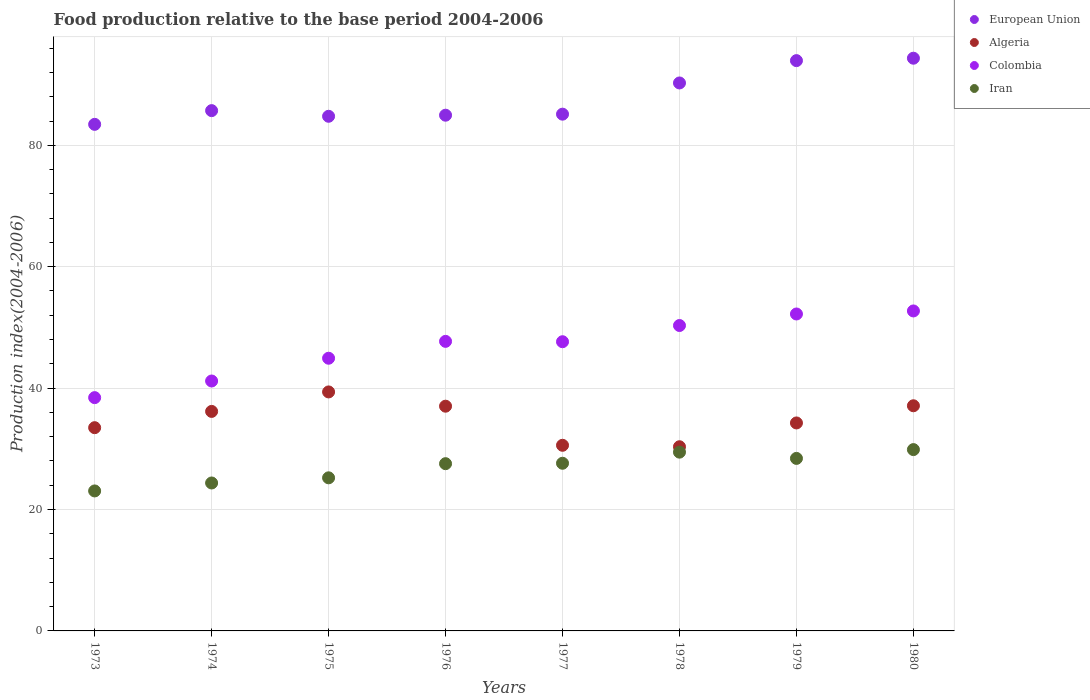Is the number of dotlines equal to the number of legend labels?
Ensure brevity in your answer.  Yes. What is the food production index in European Union in 1979?
Your answer should be compact. 93.95. Across all years, what is the maximum food production index in Colombia?
Provide a short and direct response. 52.71. Across all years, what is the minimum food production index in Iran?
Offer a terse response. 23.06. In which year was the food production index in Iran minimum?
Your answer should be compact. 1973. What is the total food production index in European Union in the graph?
Your response must be concise. 702.58. What is the difference between the food production index in Colombia in 1976 and that in 1979?
Keep it short and to the point. -4.51. What is the difference between the food production index in Colombia in 1979 and the food production index in Algeria in 1978?
Offer a very short reply. 21.87. What is the average food production index in Iran per year?
Offer a terse response. 26.95. In the year 1979, what is the difference between the food production index in Iran and food production index in Colombia?
Provide a short and direct response. -23.79. In how many years, is the food production index in Colombia greater than 60?
Your response must be concise. 0. What is the ratio of the food production index in European Union in 1978 to that in 1980?
Your response must be concise. 0.96. Is the food production index in European Union in 1974 less than that in 1980?
Ensure brevity in your answer.  Yes. Is the difference between the food production index in Iran in 1973 and 1975 greater than the difference between the food production index in Colombia in 1973 and 1975?
Your answer should be very brief. Yes. What is the difference between the highest and the lowest food production index in European Union?
Ensure brevity in your answer.  10.89. Is the sum of the food production index in European Union in 1974 and 1980 greater than the maximum food production index in Iran across all years?
Ensure brevity in your answer.  Yes. Does the food production index in Algeria monotonically increase over the years?
Keep it short and to the point. No. Is the food production index in Algeria strictly greater than the food production index in European Union over the years?
Your answer should be very brief. No. Is the food production index in European Union strictly less than the food production index in Iran over the years?
Make the answer very short. No. How many dotlines are there?
Keep it short and to the point. 4. How many years are there in the graph?
Provide a short and direct response. 8. Where does the legend appear in the graph?
Your answer should be very brief. Top right. How many legend labels are there?
Offer a very short reply. 4. What is the title of the graph?
Make the answer very short. Food production relative to the base period 2004-2006. Does "Turkmenistan" appear as one of the legend labels in the graph?
Provide a short and direct response. No. What is the label or title of the Y-axis?
Your response must be concise. Production index(2004-2006). What is the Production index(2004-2006) in European Union in 1973?
Give a very brief answer. 83.45. What is the Production index(2004-2006) in Algeria in 1973?
Ensure brevity in your answer.  33.48. What is the Production index(2004-2006) in Colombia in 1973?
Your answer should be compact. 38.43. What is the Production index(2004-2006) in Iran in 1973?
Give a very brief answer. 23.06. What is the Production index(2004-2006) of European Union in 1974?
Make the answer very short. 85.71. What is the Production index(2004-2006) in Algeria in 1974?
Provide a short and direct response. 36.16. What is the Production index(2004-2006) in Colombia in 1974?
Offer a very short reply. 41.17. What is the Production index(2004-2006) of Iran in 1974?
Provide a short and direct response. 24.37. What is the Production index(2004-2006) in European Union in 1975?
Your answer should be compact. 84.78. What is the Production index(2004-2006) in Algeria in 1975?
Ensure brevity in your answer.  39.37. What is the Production index(2004-2006) of Colombia in 1975?
Offer a terse response. 44.92. What is the Production index(2004-2006) in Iran in 1975?
Your answer should be compact. 25.22. What is the Production index(2004-2006) of European Union in 1976?
Provide a succinct answer. 84.96. What is the Production index(2004-2006) of Algeria in 1976?
Your response must be concise. 37.02. What is the Production index(2004-2006) of Colombia in 1976?
Make the answer very short. 47.7. What is the Production index(2004-2006) of Iran in 1976?
Make the answer very short. 27.55. What is the Production index(2004-2006) in European Union in 1977?
Give a very brief answer. 85.13. What is the Production index(2004-2006) in Algeria in 1977?
Your answer should be compact. 30.58. What is the Production index(2004-2006) in Colombia in 1977?
Give a very brief answer. 47.64. What is the Production index(2004-2006) in Iran in 1977?
Provide a succinct answer. 27.62. What is the Production index(2004-2006) in European Union in 1978?
Offer a terse response. 90.27. What is the Production index(2004-2006) of Algeria in 1978?
Give a very brief answer. 30.34. What is the Production index(2004-2006) in Colombia in 1978?
Keep it short and to the point. 50.31. What is the Production index(2004-2006) of Iran in 1978?
Your answer should be very brief. 29.45. What is the Production index(2004-2006) in European Union in 1979?
Make the answer very short. 93.95. What is the Production index(2004-2006) of Algeria in 1979?
Your response must be concise. 34.26. What is the Production index(2004-2006) of Colombia in 1979?
Your answer should be very brief. 52.21. What is the Production index(2004-2006) of Iran in 1979?
Offer a very short reply. 28.42. What is the Production index(2004-2006) of European Union in 1980?
Your answer should be very brief. 94.34. What is the Production index(2004-2006) of Algeria in 1980?
Your answer should be very brief. 37.09. What is the Production index(2004-2006) of Colombia in 1980?
Provide a succinct answer. 52.71. What is the Production index(2004-2006) in Iran in 1980?
Your answer should be very brief. 29.87. Across all years, what is the maximum Production index(2004-2006) in European Union?
Your answer should be very brief. 94.34. Across all years, what is the maximum Production index(2004-2006) of Algeria?
Keep it short and to the point. 39.37. Across all years, what is the maximum Production index(2004-2006) in Colombia?
Provide a succinct answer. 52.71. Across all years, what is the maximum Production index(2004-2006) of Iran?
Offer a terse response. 29.87. Across all years, what is the minimum Production index(2004-2006) of European Union?
Provide a succinct answer. 83.45. Across all years, what is the minimum Production index(2004-2006) of Algeria?
Your answer should be very brief. 30.34. Across all years, what is the minimum Production index(2004-2006) in Colombia?
Give a very brief answer. 38.43. Across all years, what is the minimum Production index(2004-2006) of Iran?
Your answer should be very brief. 23.06. What is the total Production index(2004-2006) in European Union in the graph?
Give a very brief answer. 702.58. What is the total Production index(2004-2006) of Algeria in the graph?
Provide a succinct answer. 278.3. What is the total Production index(2004-2006) of Colombia in the graph?
Offer a terse response. 375.09. What is the total Production index(2004-2006) of Iran in the graph?
Ensure brevity in your answer.  215.56. What is the difference between the Production index(2004-2006) in European Union in 1973 and that in 1974?
Give a very brief answer. -2.26. What is the difference between the Production index(2004-2006) in Algeria in 1973 and that in 1974?
Ensure brevity in your answer.  -2.68. What is the difference between the Production index(2004-2006) in Colombia in 1973 and that in 1974?
Ensure brevity in your answer.  -2.74. What is the difference between the Production index(2004-2006) in Iran in 1973 and that in 1974?
Your answer should be very brief. -1.31. What is the difference between the Production index(2004-2006) of European Union in 1973 and that in 1975?
Make the answer very short. -1.33. What is the difference between the Production index(2004-2006) in Algeria in 1973 and that in 1975?
Keep it short and to the point. -5.89. What is the difference between the Production index(2004-2006) in Colombia in 1973 and that in 1975?
Offer a terse response. -6.49. What is the difference between the Production index(2004-2006) in Iran in 1973 and that in 1975?
Make the answer very short. -2.16. What is the difference between the Production index(2004-2006) in European Union in 1973 and that in 1976?
Keep it short and to the point. -1.51. What is the difference between the Production index(2004-2006) of Algeria in 1973 and that in 1976?
Ensure brevity in your answer.  -3.54. What is the difference between the Production index(2004-2006) in Colombia in 1973 and that in 1976?
Your response must be concise. -9.27. What is the difference between the Production index(2004-2006) in Iran in 1973 and that in 1976?
Provide a short and direct response. -4.49. What is the difference between the Production index(2004-2006) in European Union in 1973 and that in 1977?
Provide a succinct answer. -1.68. What is the difference between the Production index(2004-2006) of Colombia in 1973 and that in 1977?
Offer a very short reply. -9.21. What is the difference between the Production index(2004-2006) in Iran in 1973 and that in 1977?
Your answer should be very brief. -4.56. What is the difference between the Production index(2004-2006) of European Union in 1973 and that in 1978?
Your response must be concise. -6.82. What is the difference between the Production index(2004-2006) of Algeria in 1973 and that in 1978?
Provide a short and direct response. 3.14. What is the difference between the Production index(2004-2006) of Colombia in 1973 and that in 1978?
Ensure brevity in your answer.  -11.88. What is the difference between the Production index(2004-2006) of Iran in 1973 and that in 1978?
Offer a very short reply. -6.39. What is the difference between the Production index(2004-2006) of European Union in 1973 and that in 1979?
Make the answer very short. -10.5. What is the difference between the Production index(2004-2006) in Algeria in 1973 and that in 1979?
Your answer should be compact. -0.78. What is the difference between the Production index(2004-2006) in Colombia in 1973 and that in 1979?
Give a very brief answer. -13.78. What is the difference between the Production index(2004-2006) of Iran in 1973 and that in 1979?
Give a very brief answer. -5.36. What is the difference between the Production index(2004-2006) in European Union in 1973 and that in 1980?
Offer a terse response. -10.89. What is the difference between the Production index(2004-2006) in Algeria in 1973 and that in 1980?
Offer a very short reply. -3.61. What is the difference between the Production index(2004-2006) in Colombia in 1973 and that in 1980?
Give a very brief answer. -14.28. What is the difference between the Production index(2004-2006) in Iran in 1973 and that in 1980?
Make the answer very short. -6.81. What is the difference between the Production index(2004-2006) of European Union in 1974 and that in 1975?
Your answer should be very brief. 0.93. What is the difference between the Production index(2004-2006) of Algeria in 1974 and that in 1975?
Your answer should be compact. -3.21. What is the difference between the Production index(2004-2006) in Colombia in 1974 and that in 1975?
Your answer should be compact. -3.75. What is the difference between the Production index(2004-2006) of Iran in 1974 and that in 1975?
Your response must be concise. -0.85. What is the difference between the Production index(2004-2006) of European Union in 1974 and that in 1976?
Your answer should be very brief. 0.75. What is the difference between the Production index(2004-2006) of Algeria in 1974 and that in 1976?
Your response must be concise. -0.86. What is the difference between the Production index(2004-2006) of Colombia in 1974 and that in 1976?
Your answer should be compact. -6.53. What is the difference between the Production index(2004-2006) of Iran in 1974 and that in 1976?
Keep it short and to the point. -3.18. What is the difference between the Production index(2004-2006) of European Union in 1974 and that in 1977?
Offer a terse response. 0.58. What is the difference between the Production index(2004-2006) in Algeria in 1974 and that in 1977?
Your response must be concise. 5.58. What is the difference between the Production index(2004-2006) in Colombia in 1974 and that in 1977?
Offer a very short reply. -6.47. What is the difference between the Production index(2004-2006) in Iran in 1974 and that in 1977?
Your answer should be very brief. -3.25. What is the difference between the Production index(2004-2006) of European Union in 1974 and that in 1978?
Offer a terse response. -4.56. What is the difference between the Production index(2004-2006) of Algeria in 1974 and that in 1978?
Give a very brief answer. 5.82. What is the difference between the Production index(2004-2006) in Colombia in 1974 and that in 1978?
Offer a very short reply. -9.14. What is the difference between the Production index(2004-2006) of Iran in 1974 and that in 1978?
Make the answer very short. -5.08. What is the difference between the Production index(2004-2006) of European Union in 1974 and that in 1979?
Make the answer very short. -8.24. What is the difference between the Production index(2004-2006) of Algeria in 1974 and that in 1979?
Make the answer very short. 1.9. What is the difference between the Production index(2004-2006) in Colombia in 1974 and that in 1979?
Ensure brevity in your answer.  -11.04. What is the difference between the Production index(2004-2006) of Iran in 1974 and that in 1979?
Your answer should be compact. -4.05. What is the difference between the Production index(2004-2006) of European Union in 1974 and that in 1980?
Your response must be concise. -8.64. What is the difference between the Production index(2004-2006) in Algeria in 1974 and that in 1980?
Give a very brief answer. -0.93. What is the difference between the Production index(2004-2006) in Colombia in 1974 and that in 1980?
Ensure brevity in your answer.  -11.54. What is the difference between the Production index(2004-2006) of European Union in 1975 and that in 1976?
Provide a succinct answer. -0.18. What is the difference between the Production index(2004-2006) in Algeria in 1975 and that in 1976?
Provide a succinct answer. 2.35. What is the difference between the Production index(2004-2006) of Colombia in 1975 and that in 1976?
Make the answer very short. -2.78. What is the difference between the Production index(2004-2006) in Iran in 1975 and that in 1976?
Make the answer very short. -2.33. What is the difference between the Production index(2004-2006) of European Union in 1975 and that in 1977?
Give a very brief answer. -0.35. What is the difference between the Production index(2004-2006) in Algeria in 1975 and that in 1977?
Ensure brevity in your answer.  8.79. What is the difference between the Production index(2004-2006) of Colombia in 1975 and that in 1977?
Give a very brief answer. -2.72. What is the difference between the Production index(2004-2006) in European Union in 1975 and that in 1978?
Keep it short and to the point. -5.49. What is the difference between the Production index(2004-2006) of Algeria in 1975 and that in 1978?
Offer a very short reply. 9.03. What is the difference between the Production index(2004-2006) in Colombia in 1975 and that in 1978?
Keep it short and to the point. -5.39. What is the difference between the Production index(2004-2006) of Iran in 1975 and that in 1978?
Provide a short and direct response. -4.23. What is the difference between the Production index(2004-2006) of European Union in 1975 and that in 1979?
Keep it short and to the point. -9.17. What is the difference between the Production index(2004-2006) in Algeria in 1975 and that in 1979?
Your answer should be very brief. 5.11. What is the difference between the Production index(2004-2006) of Colombia in 1975 and that in 1979?
Your answer should be very brief. -7.29. What is the difference between the Production index(2004-2006) in Iran in 1975 and that in 1979?
Offer a very short reply. -3.2. What is the difference between the Production index(2004-2006) in European Union in 1975 and that in 1980?
Offer a terse response. -9.57. What is the difference between the Production index(2004-2006) in Algeria in 1975 and that in 1980?
Your response must be concise. 2.28. What is the difference between the Production index(2004-2006) in Colombia in 1975 and that in 1980?
Offer a terse response. -7.79. What is the difference between the Production index(2004-2006) of Iran in 1975 and that in 1980?
Offer a terse response. -4.65. What is the difference between the Production index(2004-2006) in European Union in 1976 and that in 1977?
Provide a succinct answer. -0.17. What is the difference between the Production index(2004-2006) in Algeria in 1976 and that in 1977?
Your answer should be very brief. 6.44. What is the difference between the Production index(2004-2006) in Iran in 1976 and that in 1977?
Provide a succinct answer. -0.07. What is the difference between the Production index(2004-2006) in European Union in 1976 and that in 1978?
Make the answer very short. -5.31. What is the difference between the Production index(2004-2006) in Algeria in 1976 and that in 1978?
Offer a terse response. 6.68. What is the difference between the Production index(2004-2006) of Colombia in 1976 and that in 1978?
Keep it short and to the point. -2.61. What is the difference between the Production index(2004-2006) in European Union in 1976 and that in 1979?
Your answer should be compact. -8.99. What is the difference between the Production index(2004-2006) in Algeria in 1976 and that in 1979?
Your answer should be compact. 2.76. What is the difference between the Production index(2004-2006) of Colombia in 1976 and that in 1979?
Keep it short and to the point. -4.51. What is the difference between the Production index(2004-2006) of Iran in 1976 and that in 1979?
Provide a short and direct response. -0.87. What is the difference between the Production index(2004-2006) of European Union in 1976 and that in 1980?
Give a very brief answer. -9.39. What is the difference between the Production index(2004-2006) of Algeria in 1976 and that in 1980?
Your response must be concise. -0.07. What is the difference between the Production index(2004-2006) of Colombia in 1976 and that in 1980?
Your answer should be compact. -5.01. What is the difference between the Production index(2004-2006) of Iran in 1976 and that in 1980?
Your answer should be compact. -2.32. What is the difference between the Production index(2004-2006) in European Union in 1977 and that in 1978?
Provide a succinct answer. -5.14. What is the difference between the Production index(2004-2006) in Algeria in 1977 and that in 1978?
Your answer should be very brief. 0.24. What is the difference between the Production index(2004-2006) of Colombia in 1977 and that in 1978?
Your answer should be very brief. -2.67. What is the difference between the Production index(2004-2006) of Iran in 1977 and that in 1978?
Offer a very short reply. -1.83. What is the difference between the Production index(2004-2006) in European Union in 1977 and that in 1979?
Ensure brevity in your answer.  -8.82. What is the difference between the Production index(2004-2006) of Algeria in 1977 and that in 1979?
Keep it short and to the point. -3.68. What is the difference between the Production index(2004-2006) of Colombia in 1977 and that in 1979?
Keep it short and to the point. -4.57. What is the difference between the Production index(2004-2006) in Iran in 1977 and that in 1979?
Keep it short and to the point. -0.8. What is the difference between the Production index(2004-2006) of European Union in 1977 and that in 1980?
Give a very brief answer. -9.22. What is the difference between the Production index(2004-2006) of Algeria in 1977 and that in 1980?
Ensure brevity in your answer.  -6.51. What is the difference between the Production index(2004-2006) of Colombia in 1977 and that in 1980?
Give a very brief answer. -5.07. What is the difference between the Production index(2004-2006) of Iran in 1977 and that in 1980?
Provide a short and direct response. -2.25. What is the difference between the Production index(2004-2006) in European Union in 1978 and that in 1979?
Your answer should be very brief. -3.68. What is the difference between the Production index(2004-2006) of Algeria in 1978 and that in 1979?
Give a very brief answer. -3.92. What is the difference between the Production index(2004-2006) in Iran in 1978 and that in 1979?
Make the answer very short. 1.03. What is the difference between the Production index(2004-2006) of European Union in 1978 and that in 1980?
Make the answer very short. -4.08. What is the difference between the Production index(2004-2006) in Algeria in 1978 and that in 1980?
Offer a terse response. -6.75. What is the difference between the Production index(2004-2006) in Iran in 1978 and that in 1980?
Ensure brevity in your answer.  -0.42. What is the difference between the Production index(2004-2006) of European Union in 1979 and that in 1980?
Give a very brief answer. -0.4. What is the difference between the Production index(2004-2006) in Algeria in 1979 and that in 1980?
Give a very brief answer. -2.83. What is the difference between the Production index(2004-2006) in Iran in 1979 and that in 1980?
Keep it short and to the point. -1.45. What is the difference between the Production index(2004-2006) in European Union in 1973 and the Production index(2004-2006) in Algeria in 1974?
Provide a succinct answer. 47.29. What is the difference between the Production index(2004-2006) of European Union in 1973 and the Production index(2004-2006) of Colombia in 1974?
Your answer should be very brief. 42.28. What is the difference between the Production index(2004-2006) of European Union in 1973 and the Production index(2004-2006) of Iran in 1974?
Make the answer very short. 59.08. What is the difference between the Production index(2004-2006) of Algeria in 1973 and the Production index(2004-2006) of Colombia in 1974?
Offer a terse response. -7.69. What is the difference between the Production index(2004-2006) of Algeria in 1973 and the Production index(2004-2006) of Iran in 1974?
Your answer should be very brief. 9.11. What is the difference between the Production index(2004-2006) of Colombia in 1973 and the Production index(2004-2006) of Iran in 1974?
Offer a terse response. 14.06. What is the difference between the Production index(2004-2006) in European Union in 1973 and the Production index(2004-2006) in Algeria in 1975?
Make the answer very short. 44.08. What is the difference between the Production index(2004-2006) of European Union in 1973 and the Production index(2004-2006) of Colombia in 1975?
Provide a short and direct response. 38.53. What is the difference between the Production index(2004-2006) in European Union in 1973 and the Production index(2004-2006) in Iran in 1975?
Ensure brevity in your answer.  58.23. What is the difference between the Production index(2004-2006) of Algeria in 1973 and the Production index(2004-2006) of Colombia in 1975?
Offer a terse response. -11.44. What is the difference between the Production index(2004-2006) of Algeria in 1973 and the Production index(2004-2006) of Iran in 1975?
Ensure brevity in your answer.  8.26. What is the difference between the Production index(2004-2006) in Colombia in 1973 and the Production index(2004-2006) in Iran in 1975?
Keep it short and to the point. 13.21. What is the difference between the Production index(2004-2006) of European Union in 1973 and the Production index(2004-2006) of Algeria in 1976?
Your answer should be very brief. 46.43. What is the difference between the Production index(2004-2006) of European Union in 1973 and the Production index(2004-2006) of Colombia in 1976?
Offer a very short reply. 35.75. What is the difference between the Production index(2004-2006) of European Union in 1973 and the Production index(2004-2006) of Iran in 1976?
Provide a short and direct response. 55.9. What is the difference between the Production index(2004-2006) in Algeria in 1973 and the Production index(2004-2006) in Colombia in 1976?
Offer a terse response. -14.22. What is the difference between the Production index(2004-2006) in Algeria in 1973 and the Production index(2004-2006) in Iran in 1976?
Keep it short and to the point. 5.93. What is the difference between the Production index(2004-2006) in Colombia in 1973 and the Production index(2004-2006) in Iran in 1976?
Your answer should be very brief. 10.88. What is the difference between the Production index(2004-2006) in European Union in 1973 and the Production index(2004-2006) in Algeria in 1977?
Offer a terse response. 52.87. What is the difference between the Production index(2004-2006) of European Union in 1973 and the Production index(2004-2006) of Colombia in 1977?
Your response must be concise. 35.81. What is the difference between the Production index(2004-2006) in European Union in 1973 and the Production index(2004-2006) in Iran in 1977?
Offer a terse response. 55.83. What is the difference between the Production index(2004-2006) of Algeria in 1973 and the Production index(2004-2006) of Colombia in 1977?
Your response must be concise. -14.16. What is the difference between the Production index(2004-2006) of Algeria in 1973 and the Production index(2004-2006) of Iran in 1977?
Provide a short and direct response. 5.86. What is the difference between the Production index(2004-2006) in Colombia in 1973 and the Production index(2004-2006) in Iran in 1977?
Your answer should be very brief. 10.81. What is the difference between the Production index(2004-2006) of European Union in 1973 and the Production index(2004-2006) of Algeria in 1978?
Offer a very short reply. 53.11. What is the difference between the Production index(2004-2006) of European Union in 1973 and the Production index(2004-2006) of Colombia in 1978?
Your answer should be very brief. 33.14. What is the difference between the Production index(2004-2006) in European Union in 1973 and the Production index(2004-2006) in Iran in 1978?
Give a very brief answer. 54. What is the difference between the Production index(2004-2006) of Algeria in 1973 and the Production index(2004-2006) of Colombia in 1978?
Your response must be concise. -16.83. What is the difference between the Production index(2004-2006) in Algeria in 1973 and the Production index(2004-2006) in Iran in 1978?
Ensure brevity in your answer.  4.03. What is the difference between the Production index(2004-2006) in Colombia in 1973 and the Production index(2004-2006) in Iran in 1978?
Keep it short and to the point. 8.98. What is the difference between the Production index(2004-2006) in European Union in 1973 and the Production index(2004-2006) in Algeria in 1979?
Your answer should be compact. 49.19. What is the difference between the Production index(2004-2006) in European Union in 1973 and the Production index(2004-2006) in Colombia in 1979?
Provide a succinct answer. 31.24. What is the difference between the Production index(2004-2006) of European Union in 1973 and the Production index(2004-2006) of Iran in 1979?
Provide a short and direct response. 55.03. What is the difference between the Production index(2004-2006) in Algeria in 1973 and the Production index(2004-2006) in Colombia in 1979?
Provide a succinct answer. -18.73. What is the difference between the Production index(2004-2006) in Algeria in 1973 and the Production index(2004-2006) in Iran in 1979?
Your answer should be compact. 5.06. What is the difference between the Production index(2004-2006) of Colombia in 1973 and the Production index(2004-2006) of Iran in 1979?
Provide a short and direct response. 10.01. What is the difference between the Production index(2004-2006) in European Union in 1973 and the Production index(2004-2006) in Algeria in 1980?
Offer a terse response. 46.36. What is the difference between the Production index(2004-2006) in European Union in 1973 and the Production index(2004-2006) in Colombia in 1980?
Give a very brief answer. 30.74. What is the difference between the Production index(2004-2006) of European Union in 1973 and the Production index(2004-2006) of Iran in 1980?
Provide a short and direct response. 53.58. What is the difference between the Production index(2004-2006) in Algeria in 1973 and the Production index(2004-2006) in Colombia in 1980?
Make the answer very short. -19.23. What is the difference between the Production index(2004-2006) in Algeria in 1973 and the Production index(2004-2006) in Iran in 1980?
Provide a succinct answer. 3.61. What is the difference between the Production index(2004-2006) in Colombia in 1973 and the Production index(2004-2006) in Iran in 1980?
Your answer should be compact. 8.56. What is the difference between the Production index(2004-2006) of European Union in 1974 and the Production index(2004-2006) of Algeria in 1975?
Your answer should be very brief. 46.34. What is the difference between the Production index(2004-2006) of European Union in 1974 and the Production index(2004-2006) of Colombia in 1975?
Your answer should be compact. 40.79. What is the difference between the Production index(2004-2006) of European Union in 1974 and the Production index(2004-2006) of Iran in 1975?
Provide a short and direct response. 60.49. What is the difference between the Production index(2004-2006) in Algeria in 1974 and the Production index(2004-2006) in Colombia in 1975?
Keep it short and to the point. -8.76. What is the difference between the Production index(2004-2006) in Algeria in 1974 and the Production index(2004-2006) in Iran in 1975?
Your response must be concise. 10.94. What is the difference between the Production index(2004-2006) of Colombia in 1974 and the Production index(2004-2006) of Iran in 1975?
Give a very brief answer. 15.95. What is the difference between the Production index(2004-2006) of European Union in 1974 and the Production index(2004-2006) of Algeria in 1976?
Make the answer very short. 48.69. What is the difference between the Production index(2004-2006) in European Union in 1974 and the Production index(2004-2006) in Colombia in 1976?
Give a very brief answer. 38.01. What is the difference between the Production index(2004-2006) in European Union in 1974 and the Production index(2004-2006) in Iran in 1976?
Offer a terse response. 58.16. What is the difference between the Production index(2004-2006) in Algeria in 1974 and the Production index(2004-2006) in Colombia in 1976?
Offer a very short reply. -11.54. What is the difference between the Production index(2004-2006) of Algeria in 1974 and the Production index(2004-2006) of Iran in 1976?
Keep it short and to the point. 8.61. What is the difference between the Production index(2004-2006) of Colombia in 1974 and the Production index(2004-2006) of Iran in 1976?
Keep it short and to the point. 13.62. What is the difference between the Production index(2004-2006) in European Union in 1974 and the Production index(2004-2006) in Algeria in 1977?
Give a very brief answer. 55.13. What is the difference between the Production index(2004-2006) of European Union in 1974 and the Production index(2004-2006) of Colombia in 1977?
Ensure brevity in your answer.  38.07. What is the difference between the Production index(2004-2006) in European Union in 1974 and the Production index(2004-2006) in Iran in 1977?
Offer a terse response. 58.09. What is the difference between the Production index(2004-2006) in Algeria in 1974 and the Production index(2004-2006) in Colombia in 1977?
Your answer should be very brief. -11.48. What is the difference between the Production index(2004-2006) in Algeria in 1974 and the Production index(2004-2006) in Iran in 1977?
Your response must be concise. 8.54. What is the difference between the Production index(2004-2006) of Colombia in 1974 and the Production index(2004-2006) of Iran in 1977?
Ensure brevity in your answer.  13.55. What is the difference between the Production index(2004-2006) of European Union in 1974 and the Production index(2004-2006) of Algeria in 1978?
Provide a succinct answer. 55.37. What is the difference between the Production index(2004-2006) of European Union in 1974 and the Production index(2004-2006) of Colombia in 1978?
Your answer should be very brief. 35.4. What is the difference between the Production index(2004-2006) of European Union in 1974 and the Production index(2004-2006) of Iran in 1978?
Your answer should be compact. 56.26. What is the difference between the Production index(2004-2006) of Algeria in 1974 and the Production index(2004-2006) of Colombia in 1978?
Keep it short and to the point. -14.15. What is the difference between the Production index(2004-2006) of Algeria in 1974 and the Production index(2004-2006) of Iran in 1978?
Offer a terse response. 6.71. What is the difference between the Production index(2004-2006) of Colombia in 1974 and the Production index(2004-2006) of Iran in 1978?
Your response must be concise. 11.72. What is the difference between the Production index(2004-2006) of European Union in 1974 and the Production index(2004-2006) of Algeria in 1979?
Offer a very short reply. 51.45. What is the difference between the Production index(2004-2006) in European Union in 1974 and the Production index(2004-2006) in Colombia in 1979?
Give a very brief answer. 33.5. What is the difference between the Production index(2004-2006) in European Union in 1974 and the Production index(2004-2006) in Iran in 1979?
Ensure brevity in your answer.  57.29. What is the difference between the Production index(2004-2006) in Algeria in 1974 and the Production index(2004-2006) in Colombia in 1979?
Your answer should be compact. -16.05. What is the difference between the Production index(2004-2006) in Algeria in 1974 and the Production index(2004-2006) in Iran in 1979?
Give a very brief answer. 7.74. What is the difference between the Production index(2004-2006) in Colombia in 1974 and the Production index(2004-2006) in Iran in 1979?
Keep it short and to the point. 12.75. What is the difference between the Production index(2004-2006) of European Union in 1974 and the Production index(2004-2006) of Algeria in 1980?
Ensure brevity in your answer.  48.62. What is the difference between the Production index(2004-2006) in European Union in 1974 and the Production index(2004-2006) in Colombia in 1980?
Provide a succinct answer. 33. What is the difference between the Production index(2004-2006) in European Union in 1974 and the Production index(2004-2006) in Iran in 1980?
Your response must be concise. 55.84. What is the difference between the Production index(2004-2006) of Algeria in 1974 and the Production index(2004-2006) of Colombia in 1980?
Your response must be concise. -16.55. What is the difference between the Production index(2004-2006) in Algeria in 1974 and the Production index(2004-2006) in Iran in 1980?
Provide a succinct answer. 6.29. What is the difference between the Production index(2004-2006) of European Union in 1975 and the Production index(2004-2006) of Algeria in 1976?
Offer a terse response. 47.76. What is the difference between the Production index(2004-2006) of European Union in 1975 and the Production index(2004-2006) of Colombia in 1976?
Your answer should be very brief. 37.08. What is the difference between the Production index(2004-2006) in European Union in 1975 and the Production index(2004-2006) in Iran in 1976?
Provide a short and direct response. 57.23. What is the difference between the Production index(2004-2006) of Algeria in 1975 and the Production index(2004-2006) of Colombia in 1976?
Give a very brief answer. -8.33. What is the difference between the Production index(2004-2006) of Algeria in 1975 and the Production index(2004-2006) of Iran in 1976?
Offer a very short reply. 11.82. What is the difference between the Production index(2004-2006) in Colombia in 1975 and the Production index(2004-2006) in Iran in 1976?
Give a very brief answer. 17.37. What is the difference between the Production index(2004-2006) of European Union in 1975 and the Production index(2004-2006) of Algeria in 1977?
Provide a short and direct response. 54.2. What is the difference between the Production index(2004-2006) of European Union in 1975 and the Production index(2004-2006) of Colombia in 1977?
Offer a terse response. 37.14. What is the difference between the Production index(2004-2006) in European Union in 1975 and the Production index(2004-2006) in Iran in 1977?
Ensure brevity in your answer.  57.16. What is the difference between the Production index(2004-2006) of Algeria in 1975 and the Production index(2004-2006) of Colombia in 1977?
Your answer should be very brief. -8.27. What is the difference between the Production index(2004-2006) in Algeria in 1975 and the Production index(2004-2006) in Iran in 1977?
Give a very brief answer. 11.75. What is the difference between the Production index(2004-2006) in Colombia in 1975 and the Production index(2004-2006) in Iran in 1977?
Your response must be concise. 17.3. What is the difference between the Production index(2004-2006) of European Union in 1975 and the Production index(2004-2006) of Algeria in 1978?
Make the answer very short. 54.44. What is the difference between the Production index(2004-2006) in European Union in 1975 and the Production index(2004-2006) in Colombia in 1978?
Provide a succinct answer. 34.47. What is the difference between the Production index(2004-2006) in European Union in 1975 and the Production index(2004-2006) in Iran in 1978?
Give a very brief answer. 55.33. What is the difference between the Production index(2004-2006) of Algeria in 1975 and the Production index(2004-2006) of Colombia in 1978?
Make the answer very short. -10.94. What is the difference between the Production index(2004-2006) in Algeria in 1975 and the Production index(2004-2006) in Iran in 1978?
Your answer should be very brief. 9.92. What is the difference between the Production index(2004-2006) in Colombia in 1975 and the Production index(2004-2006) in Iran in 1978?
Provide a short and direct response. 15.47. What is the difference between the Production index(2004-2006) in European Union in 1975 and the Production index(2004-2006) in Algeria in 1979?
Offer a terse response. 50.52. What is the difference between the Production index(2004-2006) of European Union in 1975 and the Production index(2004-2006) of Colombia in 1979?
Your response must be concise. 32.57. What is the difference between the Production index(2004-2006) of European Union in 1975 and the Production index(2004-2006) of Iran in 1979?
Keep it short and to the point. 56.36. What is the difference between the Production index(2004-2006) in Algeria in 1975 and the Production index(2004-2006) in Colombia in 1979?
Your answer should be compact. -12.84. What is the difference between the Production index(2004-2006) in Algeria in 1975 and the Production index(2004-2006) in Iran in 1979?
Make the answer very short. 10.95. What is the difference between the Production index(2004-2006) of European Union in 1975 and the Production index(2004-2006) of Algeria in 1980?
Ensure brevity in your answer.  47.69. What is the difference between the Production index(2004-2006) in European Union in 1975 and the Production index(2004-2006) in Colombia in 1980?
Provide a succinct answer. 32.07. What is the difference between the Production index(2004-2006) in European Union in 1975 and the Production index(2004-2006) in Iran in 1980?
Provide a succinct answer. 54.91. What is the difference between the Production index(2004-2006) of Algeria in 1975 and the Production index(2004-2006) of Colombia in 1980?
Your answer should be very brief. -13.34. What is the difference between the Production index(2004-2006) in Algeria in 1975 and the Production index(2004-2006) in Iran in 1980?
Your answer should be compact. 9.5. What is the difference between the Production index(2004-2006) of Colombia in 1975 and the Production index(2004-2006) of Iran in 1980?
Provide a short and direct response. 15.05. What is the difference between the Production index(2004-2006) in European Union in 1976 and the Production index(2004-2006) in Algeria in 1977?
Provide a succinct answer. 54.38. What is the difference between the Production index(2004-2006) of European Union in 1976 and the Production index(2004-2006) of Colombia in 1977?
Your answer should be very brief. 37.32. What is the difference between the Production index(2004-2006) in European Union in 1976 and the Production index(2004-2006) in Iran in 1977?
Ensure brevity in your answer.  57.34. What is the difference between the Production index(2004-2006) in Algeria in 1976 and the Production index(2004-2006) in Colombia in 1977?
Offer a terse response. -10.62. What is the difference between the Production index(2004-2006) of Colombia in 1976 and the Production index(2004-2006) of Iran in 1977?
Provide a short and direct response. 20.08. What is the difference between the Production index(2004-2006) in European Union in 1976 and the Production index(2004-2006) in Algeria in 1978?
Offer a terse response. 54.62. What is the difference between the Production index(2004-2006) of European Union in 1976 and the Production index(2004-2006) of Colombia in 1978?
Make the answer very short. 34.65. What is the difference between the Production index(2004-2006) in European Union in 1976 and the Production index(2004-2006) in Iran in 1978?
Keep it short and to the point. 55.51. What is the difference between the Production index(2004-2006) of Algeria in 1976 and the Production index(2004-2006) of Colombia in 1978?
Offer a very short reply. -13.29. What is the difference between the Production index(2004-2006) of Algeria in 1976 and the Production index(2004-2006) of Iran in 1978?
Offer a very short reply. 7.57. What is the difference between the Production index(2004-2006) of Colombia in 1976 and the Production index(2004-2006) of Iran in 1978?
Your response must be concise. 18.25. What is the difference between the Production index(2004-2006) of European Union in 1976 and the Production index(2004-2006) of Algeria in 1979?
Ensure brevity in your answer.  50.7. What is the difference between the Production index(2004-2006) of European Union in 1976 and the Production index(2004-2006) of Colombia in 1979?
Provide a short and direct response. 32.75. What is the difference between the Production index(2004-2006) of European Union in 1976 and the Production index(2004-2006) of Iran in 1979?
Provide a succinct answer. 56.54. What is the difference between the Production index(2004-2006) of Algeria in 1976 and the Production index(2004-2006) of Colombia in 1979?
Make the answer very short. -15.19. What is the difference between the Production index(2004-2006) in Colombia in 1976 and the Production index(2004-2006) in Iran in 1979?
Make the answer very short. 19.28. What is the difference between the Production index(2004-2006) in European Union in 1976 and the Production index(2004-2006) in Algeria in 1980?
Offer a very short reply. 47.87. What is the difference between the Production index(2004-2006) in European Union in 1976 and the Production index(2004-2006) in Colombia in 1980?
Provide a short and direct response. 32.25. What is the difference between the Production index(2004-2006) in European Union in 1976 and the Production index(2004-2006) in Iran in 1980?
Provide a succinct answer. 55.09. What is the difference between the Production index(2004-2006) of Algeria in 1976 and the Production index(2004-2006) of Colombia in 1980?
Provide a succinct answer. -15.69. What is the difference between the Production index(2004-2006) of Algeria in 1976 and the Production index(2004-2006) of Iran in 1980?
Give a very brief answer. 7.15. What is the difference between the Production index(2004-2006) in Colombia in 1976 and the Production index(2004-2006) in Iran in 1980?
Offer a very short reply. 17.83. What is the difference between the Production index(2004-2006) in European Union in 1977 and the Production index(2004-2006) in Algeria in 1978?
Offer a terse response. 54.79. What is the difference between the Production index(2004-2006) in European Union in 1977 and the Production index(2004-2006) in Colombia in 1978?
Provide a succinct answer. 34.82. What is the difference between the Production index(2004-2006) of European Union in 1977 and the Production index(2004-2006) of Iran in 1978?
Give a very brief answer. 55.68. What is the difference between the Production index(2004-2006) of Algeria in 1977 and the Production index(2004-2006) of Colombia in 1978?
Keep it short and to the point. -19.73. What is the difference between the Production index(2004-2006) of Algeria in 1977 and the Production index(2004-2006) of Iran in 1978?
Keep it short and to the point. 1.13. What is the difference between the Production index(2004-2006) of Colombia in 1977 and the Production index(2004-2006) of Iran in 1978?
Offer a very short reply. 18.19. What is the difference between the Production index(2004-2006) of European Union in 1977 and the Production index(2004-2006) of Algeria in 1979?
Offer a very short reply. 50.87. What is the difference between the Production index(2004-2006) of European Union in 1977 and the Production index(2004-2006) of Colombia in 1979?
Your answer should be very brief. 32.92. What is the difference between the Production index(2004-2006) of European Union in 1977 and the Production index(2004-2006) of Iran in 1979?
Your answer should be compact. 56.71. What is the difference between the Production index(2004-2006) in Algeria in 1977 and the Production index(2004-2006) in Colombia in 1979?
Give a very brief answer. -21.63. What is the difference between the Production index(2004-2006) of Algeria in 1977 and the Production index(2004-2006) of Iran in 1979?
Keep it short and to the point. 2.16. What is the difference between the Production index(2004-2006) of Colombia in 1977 and the Production index(2004-2006) of Iran in 1979?
Offer a very short reply. 19.22. What is the difference between the Production index(2004-2006) in European Union in 1977 and the Production index(2004-2006) in Algeria in 1980?
Ensure brevity in your answer.  48.04. What is the difference between the Production index(2004-2006) of European Union in 1977 and the Production index(2004-2006) of Colombia in 1980?
Give a very brief answer. 32.42. What is the difference between the Production index(2004-2006) of European Union in 1977 and the Production index(2004-2006) of Iran in 1980?
Your answer should be very brief. 55.26. What is the difference between the Production index(2004-2006) of Algeria in 1977 and the Production index(2004-2006) of Colombia in 1980?
Your response must be concise. -22.13. What is the difference between the Production index(2004-2006) in Algeria in 1977 and the Production index(2004-2006) in Iran in 1980?
Give a very brief answer. 0.71. What is the difference between the Production index(2004-2006) of Colombia in 1977 and the Production index(2004-2006) of Iran in 1980?
Ensure brevity in your answer.  17.77. What is the difference between the Production index(2004-2006) of European Union in 1978 and the Production index(2004-2006) of Algeria in 1979?
Offer a very short reply. 56.01. What is the difference between the Production index(2004-2006) of European Union in 1978 and the Production index(2004-2006) of Colombia in 1979?
Make the answer very short. 38.06. What is the difference between the Production index(2004-2006) in European Union in 1978 and the Production index(2004-2006) in Iran in 1979?
Provide a short and direct response. 61.85. What is the difference between the Production index(2004-2006) in Algeria in 1978 and the Production index(2004-2006) in Colombia in 1979?
Your answer should be compact. -21.87. What is the difference between the Production index(2004-2006) of Algeria in 1978 and the Production index(2004-2006) of Iran in 1979?
Make the answer very short. 1.92. What is the difference between the Production index(2004-2006) in Colombia in 1978 and the Production index(2004-2006) in Iran in 1979?
Ensure brevity in your answer.  21.89. What is the difference between the Production index(2004-2006) in European Union in 1978 and the Production index(2004-2006) in Algeria in 1980?
Your answer should be very brief. 53.18. What is the difference between the Production index(2004-2006) in European Union in 1978 and the Production index(2004-2006) in Colombia in 1980?
Offer a very short reply. 37.56. What is the difference between the Production index(2004-2006) of European Union in 1978 and the Production index(2004-2006) of Iran in 1980?
Provide a short and direct response. 60.4. What is the difference between the Production index(2004-2006) of Algeria in 1978 and the Production index(2004-2006) of Colombia in 1980?
Offer a terse response. -22.37. What is the difference between the Production index(2004-2006) in Algeria in 1978 and the Production index(2004-2006) in Iran in 1980?
Provide a short and direct response. 0.47. What is the difference between the Production index(2004-2006) of Colombia in 1978 and the Production index(2004-2006) of Iran in 1980?
Ensure brevity in your answer.  20.44. What is the difference between the Production index(2004-2006) of European Union in 1979 and the Production index(2004-2006) of Algeria in 1980?
Ensure brevity in your answer.  56.86. What is the difference between the Production index(2004-2006) of European Union in 1979 and the Production index(2004-2006) of Colombia in 1980?
Your response must be concise. 41.24. What is the difference between the Production index(2004-2006) in European Union in 1979 and the Production index(2004-2006) in Iran in 1980?
Your response must be concise. 64.08. What is the difference between the Production index(2004-2006) in Algeria in 1979 and the Production index(2004-2006) in Colombia in 1980?
Keep it short and to the point. -18.45. What is the difference between the Production index(2004-2006) in Algeria in 1979 and the Production index(2004-2006) in Iran in 1980?
Make the answer very short. 4.39. What is the difference between the Production index(2004-2006) of Colombia in 1979 and the Production index(2004-2006) of Iran in 1980?
Ensure brevity in your answer.  22.34. What is the average Production index(2004-2006) in European Union per year?
Provide a succinct answer. 87.82. What is the average Production index(2004-2006) of Algeria per year?
Give a very brief answer. 34.79. What is the average Production index(2004-2006) in Colombia per year?
Your answer should be compact. 46.89. What is the average Production index(2004-2006) of Iran per year?
Your answer should be very brief. 26.95. In the year 1973, what is the difference between the Production index(2004-2006) of European Union and Production index(2004-2006) of Algeria?
Provide a succinct answer. 49.97. In the year 1973, what is the difference between the Production index(2004-2006) of European Union and Production index(2004-2006) of Colombia?
Give a very brief answer. 45.02. In the year 1973, what is the difference between the Production index(2004-2006) of European Union and Production index(2004-2006) of Iran?
Your answer should be very brief. 60.39. In the year 1973, what is the difference between the Production index(2004-2006) of Algeria and Production index(2004-2006) of Colombia?
Provide a succinct answer. -4.95. In the year 1973, what is the difference between the Production index(2004-2006) in Algeria and Production index(2004-2006) in Iran?
Ensure brevity in your answer.  10.42. In the year 1973, what is the difference between the Production index(2004-2006) of Colombia and Production index(2004-2006) of Iran?
Provide a succinct answer. 15.37. In the year 1974, what is the difference between the Production index(2004-2006) of European Union and Production index(2004-2006) of Algeria?
Provide a succinct answer. 49.55. In the year 1974, what is the difference between the Production index(2004-2006) in European Union and Production index(2004-2006) in Colombia?
Ensure brevity in your answer.  44.54. In the year 1974, what is the difference between the Production index(2004-2006) in European Union and Production index(2004-2006) in Iran?
Offer a very short reply. 61.34. In the year 1974, what is the difference between the Production index(2004-2006) in Algeria and Production index(2004-2006) in Colombia?
Your answer should be compact. -5.01. In the year 1974, what is the difference between the Production index(2004-2006) of Algeria and Production index(2004-2006) of Iran?
Provide a short and direct response. 11.79. In the year 1975, what is the difference between the Production index(2004-2006) in European Union and Production index(2004-2006) in Algeria?
Keep it short and to the point. 45.41. In the year 1975, what is the difference between the Production index(2004-2006) in European Union and Production index(2004-2006) in Colombia?
Provide a succinct answer. 39.86. In the year 1975, what is the difference between the Production index(2004-2006) of European Union and Production index(2004-2006) of Iran?
Your answer should be very brief. 59.56. In the year 1975, what is the difference between the Production index(2004-2006) in Algeria and Production index(2004-2006) in Colombia?
Offer a very short reply. -5.55. In the year 1975, what is the difference between the Production index(2004-2006) in Algeria and Production index(2004-2006) in Iran?
Ensure brevity in your answer.  14.15. In the year 1975, what is the difference between the Production index(2004-2006) in Colombia and Production index(2004-2006) in Iran?
Make the answer very short. 19.7. In the year 1976, what is the difference between the Production index(2004-2006) of European Union and Production index(2004-2006) of Algeria?
Offer a very short reply. 47.94. In the year 1976, what is the difference between the Production index(2004-2006) in European Union and Production index(2004-2006) in Colombia?
Your answer should be compact. 37.26. In the year 1976, what is the difference between the Production index(2004-2006) of European Union and Production index(2004-2006) of Iran?
Ensure brevity in your answer.  57.41. In the year 1976, what is the difference between the Production index(2004-2006) in Algeria and Production index(2004-2006) in Colombia?
Your answer should be compact. -10.68. In the year 1976, what is the difference between the Production index(2004-2006) of Algeria and Production index(2004-2006) of Iran?
Make the answer very short. 9.47. In the year 1976, what is the difference between the Production index(2004-2006) in Colombia and Production index(2004-2006) in Iran?
Offer a very short reply. 20.15. In the year 1977, what is the difference between the Production index(2004-2006) of European Union and Production index(2004-2006) of Algeria?
Offer a very short reply. 54.55. In the year 1977, what is the difference between the Production index(2004-2006) of European Union and Production index(2004-2006) of Colombia?
Keep it short and to the point. 37.49. In the year 1977, what is the difference between the Production index(2004-2006) in European Union and Production index(2004-2006) in Iran?
Your answer should be very brief. 57.51. In the year 1977, what is the difference between the Production index(2004-2006) of Algeria and Production index(2004-2006) of Colombia?
Ensure brevity in your answer.  -17.06. In the year 1977, what is the difference between the Production index(2004-2006) in Algeria and Production index(2004-2006) in Iran?
Provide a short and direct response. 2.96. In the year 1977, what is the difference between the Production index(2004-2006) in Colombia and Production index(2004-2006) in Iran?
Keep it short and to the point. 20.02. In the year 1978, what is the difference between the Production index(2004-2006) in European Union and Production index(2004-2006) in Algeria?
Keep it short and to the point. 59.93. In the year 1978, what is the difference between the Production index(2004-2006) in European Union and Production index(2004-2006) in Colombia?
Offer a very short reply. 39.96. In the year 1978, what is the difference between the Production index(2004-2006) in European Union and Production index(2004-2006) in Iran?
Keep it short and to the point. 60.82. In the year 1978, what is the difference between the Production index(2004-2006) of Algeria and Production index(2004-2006) of Colombia?
Keep it short and to the point. -19.97. In the year 1978, what is the difference between the Production index(2004-2006) of Algeria and Production index(2004-2006) of Iran?
Make the answer very short. 0.89. In the year 1978, what is the difference between the Production index(2004-2006) of Colombia and Production index(2004-2006) of Iran?
Your response must be concise. 20.86. In the year 1979, what is the difference between the Production index(2004-2006) in European Union and Production index(2004-2006) in Algeria?
Provide a short and direct response. 59.69. In the year 1979, what is the difference between the Production index(2004-2006) in European Union and Production index(2004-2006) in Colombia?
Offer a terse response. 41.74. In the year 1979, what is the difference between the Production index(2004-2006) of European Union and Production index(2004-2006) of Iran?
Ensure brevity in your answer.  65.53. In the year 1979, what is the difference between the Production index(2004-2006) in Algeria and Production index(2004-2006) in Colombia?
Offer a terse response. -17.95. In the year 1979, what is the difference between the Production index(2004-2006) in Algeria and Production index(2004-2006) in Iran?
Offer a very short reply. 5.84. In the year 1979, what is the difference between the Production index(2004-2006) in Colombia and Production index(2004-2006) in Iran?
Your answer should be compact. 23.79. In the year 1980, what is the difference between the Production index(2004-2006) of European Union and Production index(2004-2006) of Algeria?
Your response must be concise. 57.25. In the year 1980, what is the difference between the Production index(2004-2006) in European Union and Production index(2004-2006) in Colombia?
Your answer should be compact. 41.63. In the year 1980, what is the difference between the Production index(2004-2006) of European Union and Production index(2004-2006) of Iran?
Provide a succinct answer. 64.47. In the year 1980, what is the difference between the Production index(2004-2006) of Algeria and Production index(2004-2006) of Colombia?
Make the answer very short. -15.62. In the year 1980, what is the difference between the Production index(2004-2006) in Algeria and Production index(2004-2006) in Iran?
Give a very brief answer. 7.22. In the year 1980, what is the difference between the Production index(2004-2006) in Colombia and Production index(2004-2006) in Iran?
Your answer should be very brief. 22.84. What is the ratio of the Production index(2004-2006) of European Union in 1973 to that in 1974?
Give a very brief answer. 0.97. What is the ratio of the Production index(2004-2006) in Algeria in 1973 to that in 1974?
Your answer should be very brief. 0.93. What is the ratio of the Production index(2004-2006) of Colombia in 1973 to that in 1974?
Keep it short and to the point. 0.93. What is the ratio of the Production index(2004-2006) of Iran in 1973 to that in 1974?
Offer a very short reply. 0.95. What is the ratio of the Production index(2004-2006) in European Union in 1973 to that in 1975?
Your response must be concise. 0.98. What is the ratio of the Production index(2004-2006) in Algeria in 1973 to that in 1975?
Provide a succinct answer. 0.85. What is the ratio of the Production index(2004-2006) of Colombia in 1973 to that in 1975?
Your answer should be compact. 0.86. What is the ratio of the Production index(2004-2006) of Iran in 1973 to that in 1975?
Your answer should be compact. 0.91. What is the ratio of the Production index(2004-2006) of European Union in 1973 to that in 1976?
Keep it short and to the point. 0.98. What is the ratio of the Production index(2004-2006) in Algeria in 1973 to that in 1976?
Give a very brief answer. 0.9. What is the ratio of the Production index(2004-2006) in Colombia in 1973 to that in 1976?
Give a very brief answer. 0.81. What is the ratio of the Production index(2004-2006) of Iran in 1973 to that in 1976?
Your answer should be very brief. 0.84. What is the ratio of the Production index(2004-2006) of European Union in 1973 to that in 1977?
Offer a terse response. 0.98. What is the ratio of the Production index(2004-2006) in Algeria in 1973 to that in 1977?
Offer a very short reply. 1.09. What is the ratio of the Production index(2004-2006) in Colombia in 1973 to that in 1977?
Your answer should be compact. 0.81. What is the ratio of the Production index(2004-2006) of Iran in 1973 to that in 1977?
Ensure brevity in your answer.  0.83. What is the ratio of the Production index(2004-2006) in European Union in 1973 to that in 1978?
Provide a short and direct response. 0.92. What is the ratio of the Production index(2004-2006) of Algeria in 1973 to that in 1978?
Your answer should be very brief. 1.1. What is the ratio of the Production index(2004-2006) of Colombia in 1973 to that in 1978?
Keep it short and to the point. 0.76. What is the ratio of the Production index(2004-2006) of Iran in 1973 to that in 1978?
Offer a terse response. 0.78. What is the ratio of the Production index(2004-2006) in European Union in 1973 to that in 1979?
Ensure brevity in your answer.  0.89. What is the ratio of the Production index(2004-2006) in Algeria in 1973 to that in 1979?
Your answer should be compact. 0.98. What is the ratio of the Production index(2004-2006) of Colombia in 1973 to that in 1979?
Provide a short and direct response. 0.74. What is the ratio of the Production index(2004-2006) of Iran in 1973 to that in 1979?
Offer a terse response. 0.81. What is the ratio of the Production index(2004-2006) in European Union in 1973 to that in 1980?
Offer a terse response. 0.88. What is the ratio of the Production index(2004-2006) of Algeria in 1973 to that in 1980?
Offer a terse response. 0.9. What is the ratio of the Production index(2004-2006) of Colombia in 1973 to that in 1980?
Offer a very short reply. 0.73. What is the ratio of the Production index(2004-2006) in Iran in 1973 to that in 1980?
Your response must be concise. 0.77. What is the ratio of the Production index(2004-2006) of Algeria in 1974 to that in 1975?
Offer a terse response. 0.92. What is the ratio of the Production index(2004-2006) of Colombia in 1974 to that in 1975?
Provide a short and direct response. 0.92. What is the ratio of the Production index(2004-2006) in Iran in 1974 to that in 1975?
Your response must be concise. 0.97. What is the ratio of the Production index(2004-2006) in European Union in 1974 to that in 1976?
Ensure brevity in your answer.  1.01. What is the ratio of the Production index(2004-2006) of Algeria in 1974 to that in 1976?
Keep it short and to the point. 0.98. What is the ratio of the Production index(2004-2006) of Colombia in 1974 to that in 1976?
Ensure brevity in your answer.  0.86. What is the ratio of the Production index(2004-2006) in Iran in 1974 to that in 1976?
Your response must be concise. 0.88. What is the ratio of the Production index(2004-2006) in European Union in 1974 to that in 1977?
Make the answer very short. 1.01. What is the ratio of the Production index(2004-2006) of Algeria in 1974 to that in 1977?
Provide a short and direct response. 1.18. What is the ratio of the Production index(2004-2006) in Colombia in 1974 to that in 1977?
Your answer should be compact. 0.86. What is the ratio of the Production index(2004-2006) of Iran in 1974 to that in 1977?
Your answer should be compact. 0.88. What is the ratio of the Production index(2004-2006) in European Union in 1974 to that in 1978?
Ensure brevity in your answer.  0.95. What is the ratio of the Production index(2004-2006) of Algeria in 1974 to that in 1978?
Offer a terse response. 1.19. What is the ratio of the Production index(2004-2006) of Colombia in 1974 to that in 1978?
Your answer should be compact. 0.82. What is the ratio of the Production index(2004-2006) of Iran in 1974 to that in 1978?
Your response must be concise. 0.83. What is the ratio of the Production index(2004-2006) in European Union in 1974 to that in 1979?
Ensure brevity in your answer.  0.91. What is the ratio of the Production index(2004-2006) in Algeria in 1974 to that in 1979?
Make the answer very short. 1.06. What is the ratio of the Production index(2004-2006) in Colombia in 1974 to that in 1979?
Give a very brief answer. 0.79. What is the ratio of the Production index(2004-2006) in Iran in 1974 to that in 1979?
Give a very brief answer. 0.86. What is the ratio of the Production index(2004-2006) in European Union in 1974 to that in 1980?
Give a very brief answer. 0.91. What is the ratio of the Production index(2004-2006) of Algeria in 1974 to that in 1980?
Your answer should be compact. 0.97. What is the ratio of the Production index(2004-2006) in Colombia in 1974 to that in 1980?
Ensure brevity in your answer.  0.78. What is the ratio of the Production index(2004-2006) of Iran in 1974 to that in 1980?
Make the answer very short. 0.82. What is the ratio of the Production index(2004-2006) in European Union in 1975 to that in 1976?
Your response must be concise. 1. What is the ratio of the Production index(2004-2006) in Algeria in 1975 to that in 1976?
Your response must be concise. 1.06. What is the ratio of the Production index(2004-2006) in Colombia in 1975 to that in 1976?
Offer a very short reply. 0.94. What is the ratio of the Production index(2004-2006) in Iran in 1975 to that in 1976?
Keep it short and to the point. 0.92. What is the ratio of the Production index(2004-2006) of European Union in 1975 to that in 1977?
Your answer should be compact. 1. What is the ratio of the Production index(2004-2006) of Algeria in 1975 to that in 1977?
Your answer should be compact. 1.29. What is the ratio of the Production index(2004-2006) in Colombia in 1975 to that in 1977?
Your response must be concise. 0.94. What is the ratio of the Production index(2004-2006) in Iran in 1975 to that in 1977?
Offer a terse response. 0.91. What is the ratio of the Production index(2004-2006) in European Union in 1975 to that in 1978?
Ensure brevity in your answer.  0.94. What is the ratio of the Production index(2004-2006) in Algeria in 1975 to that in 1978?
Ensure brevity in your answer.  1.3. What is the ratio of the Production index(2004-2006) of Colombia in 1975 to that in 1978?
Ensure brevity in your answer.  0.89. What is the ratio of the Production index(2004-2006) in Iran in 1975 to that in 1978?
Keep it short and to the point. 0.86. What is the ratio of the Production index(2004-2006) of European Union in 1975 to that in 1979?
Give a very brief answer. 0.9. What is the ratio of the Production index(2004-2006) of Algeria in 1975 to that in 1979?
Your answer should be compact. 1.15. What is the ratio of the Production index(2004-2006) in Colombia in 1975 to that in 1979?
Keep it short and to the point. 0.86. What is the ratio of the Production index(2004-2006) in Iran in 1975 to that in 1979?
Provide a succinct answer. 0.89. What is the ratio of the Production index(2004-2006) of European Union in 1975 to that in 1980?
Make the answer very short. 0.9. What is the ratio of the Production index(2004-2006) of Algeria in 1975 to that in 1980?
Your answer should be compact. 1.06. What is the ratio of the Production index(2004-2006) of Colombia in 1975 to that in 1980?
Provide a short and direct response. 0.85. What is the ratio of the Production index(2004-2006) of Iran in 1975 to that in 1980?
Ensure brevity in your answer.  0.84. What is the ratio of the Production index(2004-2006) of European Union in 1976 to that in 1977?
Keep it short and to the point. 1. What is the ratio of the Production index(2004-2006) in Algeria in 1976 to that in 1977?
Your response must be concise. 1.21. What is the ratio of the Production index(2004-2006) in Iran in 1976 to that in 1977?
Provide a succinct answer. 1. What is the ratio of the Production index(2004-2006) in Algeria in 1976 to that in 1978?
Provide a succinct answer. 1.22. What is the ratio of the Production index(2004-2006) of Colombia in 1976 to that in 1978?
Make the answer very short. 0.95. What is the ratio of the Production index(2004-2006) in Iran in 1976 to that in 1978?
Provide a succinct answer. 0.94. What is the ratio of the Production index(2004-2006) of European Union in 1976 to that in 1979?
Your answer should be compact. 0.9. What is the ratio of the Production index(2004-2006) in Algeria in 1976 to that in 1979?
Provide a succinct answer. 1.08. What is the ratio of the Production index(2004-2006) of Colombia in 1976 to that in 1979?
Your answer should be compact. 0.91. What is the ratio of the Production index(2004-2006) of Iran in 1976 to that in 1979?
Make the answer very short. 0.97. What is the ratio of the Production index(2004-2006) of European Union in 1976 to that in 1980?
Your answer should be compact. 0.9. What is the ratio of the Production index(2004-2006) of Algeria in 1976 to that in 1980?
Keep it short and to the point. 1. What is the ratio of the Production index(2004-2006) in Colombia in 1976 to that in 1980?
Provide a succinct answer. 0.91. What is the ratio of the Production index(2004-2006) of Iran in 1976 to that in 1980?
Give a very brief answer. 0.92. What is the ratio of the Production index(2004-2006) of European Union in 1977 to that in 1978?
Ensure brevity in your answer.  0.94. What is the ratio of the Production index(2004-2006) of Algeria in 1977 to that in 1978?
Keep it short and to the point. 1.01. What is the ratio of the Production index(2004-2006) in Colombia in 1977 to that in 1978?
Provide a succinct answer. 0.95. What is the ratio of the Production index(2004-2006) in Iran in 1977 to that in 1978?
Give a very brief answer. 0.94. What is the ratio of the Production index(2004-2006) in European Union in 1977 to that in 1979?
Give a very brief answer. 0.91. What is the ratio of the Production index(2004-2006) in Algeria in 1977 to that in 1979?
Offer a terse response. 0.89. What is the ratio of the Production index(2004-2006) in Colombia in 1977 to that in 1979?
Offer a terse response. 0.91. What is the ratio of the Production index(2004-2006) of Iran in 1977 to that in 1979?
Provide a short and direct response. 0.97. What is the ratio of the Production index(2004-2006) in European Union in 1977 to that in 1980?
Your response must be concise. 0.9. What is the ratio of the Production index(2004-2006) of Algeria in 1977 to that in 1980?
Keep it short and to the point. 0.82. What is the ratio of the Production index(2004-2006) of Colombia in 1977 to that in 1980?
Make the answer very short. 0.9. What is the ratio of the Production index(2004-2006) of Iran in 1977 to that in 1980?
Your answer should be very brief. 0.92. What is the ratio of the Production index(2004-2006) in European Union in 1978 to that in 1979?
Ensure brevity in your answer.  0.96. What is the ratio of the Production index(2004-2006) in Algeria in 1978 to that in 1979?
Offer a terse response. 0.89. What is the ratio of the Production index(2004-2006) in Colombia in 1978 to that in 1979?
Your answer should be very brief. 0.96. What is the ratio of the Production index(2004-2006) in Iran in 1978 to that in 1979?
Provide a succinct answer. 1.04. What is the ratio of the Production index(2004-2006) in European Union in 1978 to that in 1980?
Offer a very short reply. 0.96. What is the ratio of the Production index(2004-2006) of Algeria in 1978 to that in 1980?
Provide a succinct answer. 0.82. What is the ratio of the Production index(2004-2006) in Colombia in 1978 to that in 1980?
Keep it short and to the point. 0.95. What is the ratio of the Production index(2004-2006) in Iran in 1978 to that in 1980?
Your response must be concise. 0.99. What is the ratio of the Production index(2004-2006) of Algeria in 1979 to that in 1980?
Give a very brief answer. 0.92. What is the ratio of the Production index(2004-2006) of Iran in 1979 to that in 1980?
Provide a succinct answer. 0.95. What is the difference between the highest and the second highest Production index(2004-2006) of European Union?
Provide a short and direct response. 0.4. What is the difference between the highest and the second highest Production index(2004-2006) of Algeria?
Your response must be concise. 2.28. What is the difference between the highest and the second highest Production index(2004-2006) of Colombia?
Provide a short and direct response. 0.5. What is the difference between the highest and the second highest Production index(2004-2006) of Iran?
Your response must be concise. 0.42. What is the difference between the highest and the lowest Production index(2004-2006) in European Union?
Your answer should be compact. 10.89. What is the difference between the highest and the lowest Production index(2004-2006) in Algeria?
Make the answer very short. 9.03. What is the difference between the highest and the lowest Production index(2004-2006) in Colombia?
Provide a short and direct response. 14.28. What is the difference between the highest and the lowest Production index(2004-2006) of Iran?
Make the answer very short. 6.81. 